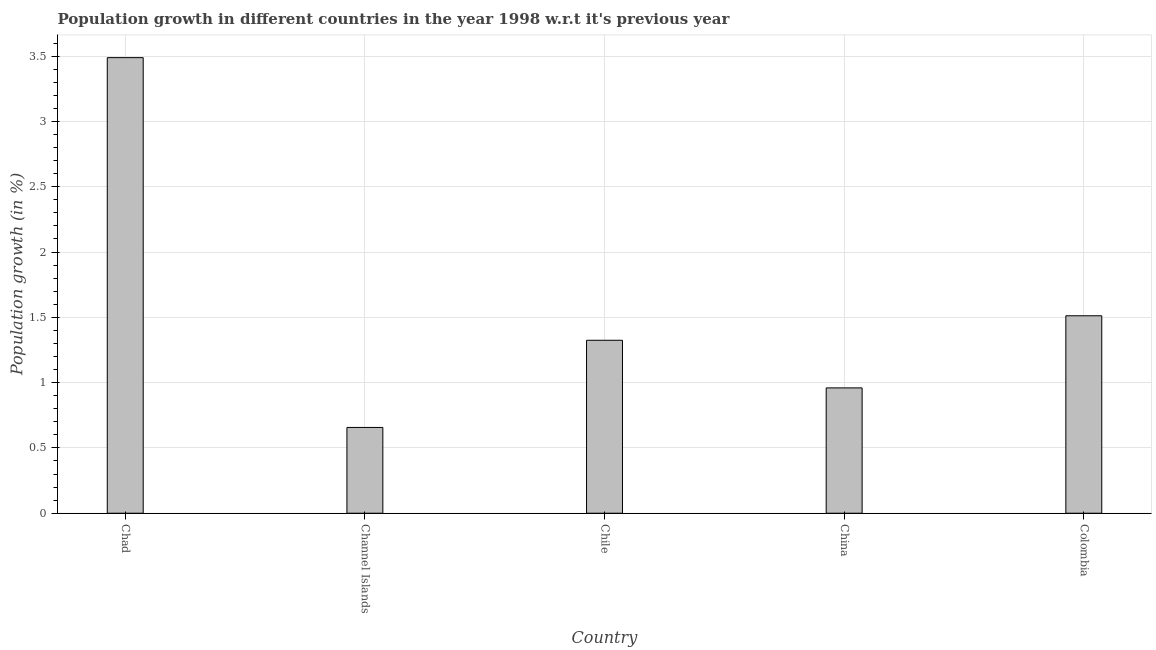Does the graph contain any zero values?
Make the answer very short. No. What is the title of the graph?
Keep it short and to the point. Population growth in different countries in the year 1998 w.r.t it's previous year. What is the label or title of the Y-axis?
Give a very brief answer. Population growth (in %). What is the population growth in Chad?
Keep it short and to the point. 3.49. Across all countries, what is the maximum population growth?
Make the answer very short. 3.49. Across all countries, what is the minimum population growth?
Your response must be concise. 0.66. In which country was the population growth maximum?
Give a very brief answer. Chad. In which country was the population growth minimum?
Provide a short and direct response. Channel Islands. What is the sum of the population growth?
Keep it short and to the point. 7.94. What is the difference between the population growth in Chad and Chile?
Provide a succinct answer. 2.16. What is the average population growth per country?
Your answer should be compact. 1.59. What is the median population growth?
Your response must be concise. 1.32. What is the ratio of the population growth in Chad to that in Chile?
Your response must be concise. 2.63. Is the population growth in Channel Islands less than that in Colombia?
Make the answer very short. Yes. Is the difference between the population growth in Channel Islands and Colombia greater than the difference between any two countries?
Keep it short and to the point. No. What is the difference between the highest and the second highest population growth?
Your answer should be compact. 1.98. Is the sum of the population growth in Chile and Colombia greater than the maximum population growth across all countries?
Make the answer very short. No. What is the difference between the highest and the lowest population growth?
Provide a short and direct response. 2.83. How many bars are there?
Give a very brief answer. 5. How many countries are there in the graph?
Make the answer very short. 5. Are the values on the major ticks of Y-axis written in scientific E-notation?
Keep it short and to the point. No. What is the Population growth (in %) of Chad?
Your answer should be compact. 3.49. What is the Population growth (in %) in Channel Islands?
Your answer should be very brief. 0.66. What is the Population growth (in %) of Chile?
Provide a short and direct response. 1.32. What is the Population growth (in %) of China?
Offer a terse response. 0.96. What is the Population growth (in %) in Colombia?
Your response must be concise. 1.51. What is the difference between the Population growth (in %) in Chad and Channel Islands?
Your answer should be compact. 2.83. What is the difference between the Population growth (in %) in Chad and Chile?
Offer a terse response. 2.16. What is the difference between the Population growth (in %) in Chad and China?
Your answer should be compact. 2.53. What is the difference between the Population growth (in %) in Chad and Colombia?
Ensure brevity in your answer.  1.98. What is the difference between the Population growth (in %) in Channel Islands and Chile?
Offer a terse response. -0.67. What is the difference between the Population growth (in %) in Channel Islands and China?
Provide a succinct answer. -0.3. What is the difference between the Population growth (in %) in Channel Islands and Colombia?
Provide a succinct answer. -0.86. What is the difference between the Population growth (in %) in Chile and China?
Provide a short and direct response. 0.36. What is the difference between the Population growth (in %) in Chile and Colombia?
Your answer should be compact. -0.19. What is the difference between the Population growth (in %) in China and Colombia?
Your response must be concise. -0.55. What is the ratio of the Population growth (in %) in Chad to that in Channel Islands?
Keep it short and to the point. 5.31. What is the ratio of the Population growth (in %) in Chad to that in Chile?
Provide a succinct answer. 2.63. What is the ratio of the Population growth (in %) in Chad to that in China?
Offer a very short reply. 3.63. What is the ratio of the Population growth (in %) in Chad to that in Colombia?
Give a very brief answer. 2.31. What is the ratio of the Population growth (in %) in Channel Islands to that in Chile?
Provide a short and direct response. 0.5. What is the ratio of the Population growth (in %) in Channel Islands to that in China?
Your answer should be very brief. 0.68. What is the ratio of the Population growth (in %) in Channel Islands to that in Colombia?
Provide a succinct answer. 0.43. What is the ratio of the Population growth (in %) in Chile to that in China?
Make the answer very short. 1.38. What is the ratio of the Population growth (in %) in Chile to that in Colombia?
Your answer should be compact. 0.88. What is the ratio of the Population growth (in %) in China to that in Colombia?
Offer a terse response. 0.64. 